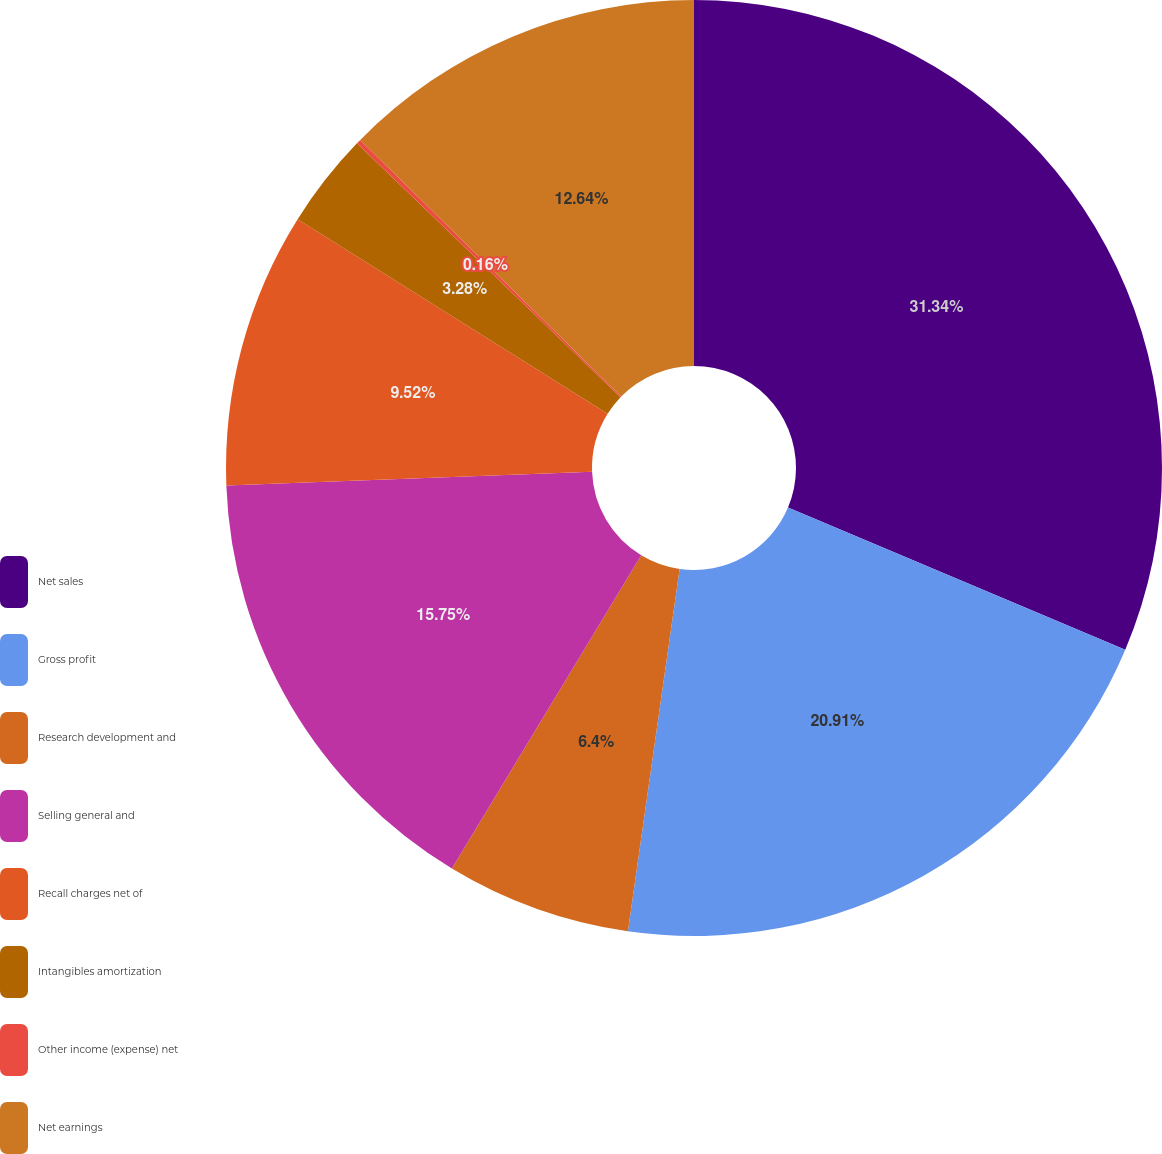Convert chart. <chart><loc_0><loc_0><loc_500><loc_500><pie_chart><fcel>Net sales<fcel>Gross profit<fcel>Research development and<fcel>Selling general and<fcel>Recall charges net of<fcel>Intangibles amortization<fcel>Other income (expense) net<fcel>Net earnings<nl><fcel>31.35%<fcel>20.91%<fcel>6.4%<fcel>15.75%<fcel>9.52%<fcel>3.28%<fcel>0.16%<fcel>12.64%<nl></chart> 